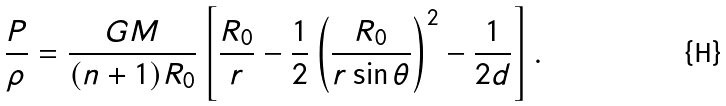Convert formula to latex. <formula><loc_0><loc_0><loc_500><loc_500>\frac { P } { \rho } = \frac { G M } { ( n + 1 ) R _ { 0 } } \left [ \frac { R _ { 0 } } { r } - \frac { 1 } { 2 } \left ( \frac { R _ { 0 } } { r \sin \theta } \right ) ^ { 2 } - \frac { 1 } { 2 d } \right ] .</formula> 